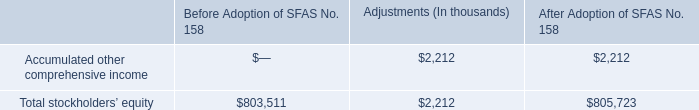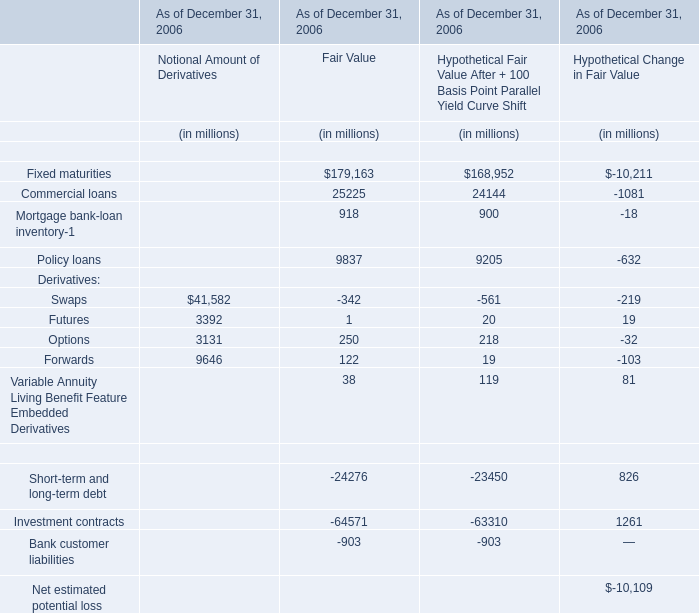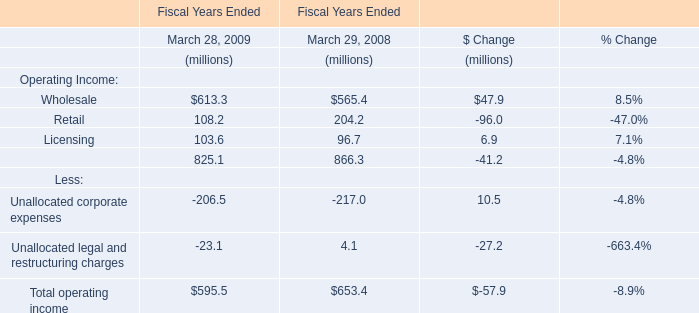what is the net change in the equity investments in non-publicly traded securities from 2008 to 2009? 
Computations: (7585 - 9278)
Answer: -1693.0. 